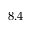Convert formula to latex. <formula><loc_0><loc_0><loc_500><loc_500>8 . 4</formula> 